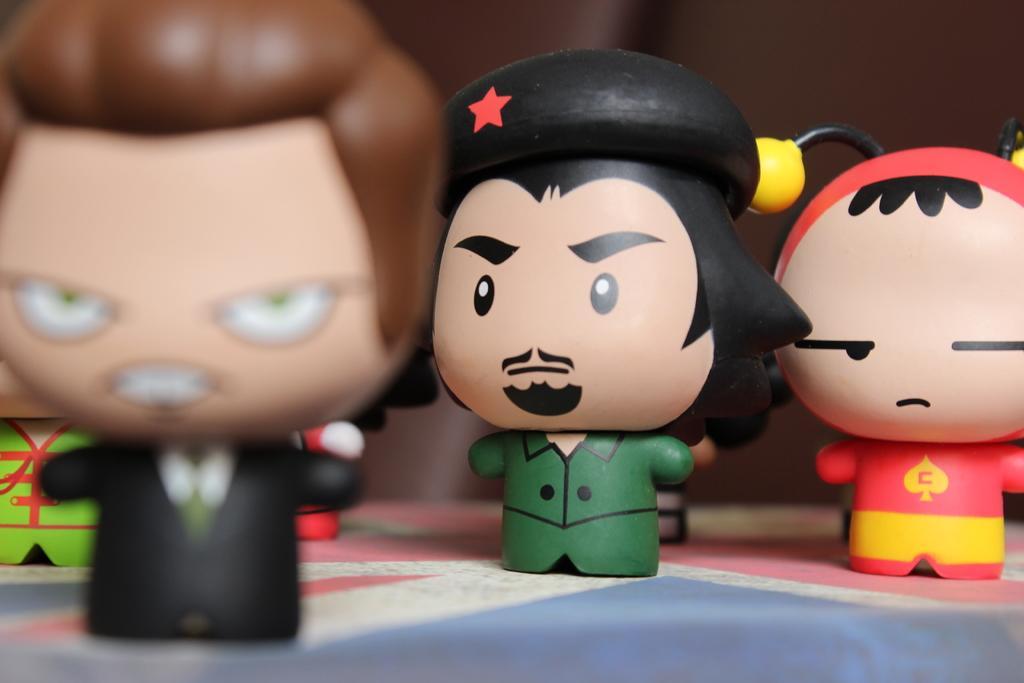Can you describe this image briefly? In the foreground of this picture we can see the toys symbolizing persons which are placed on the top of an object which seems to be the table. In the background we can see some other objects. 